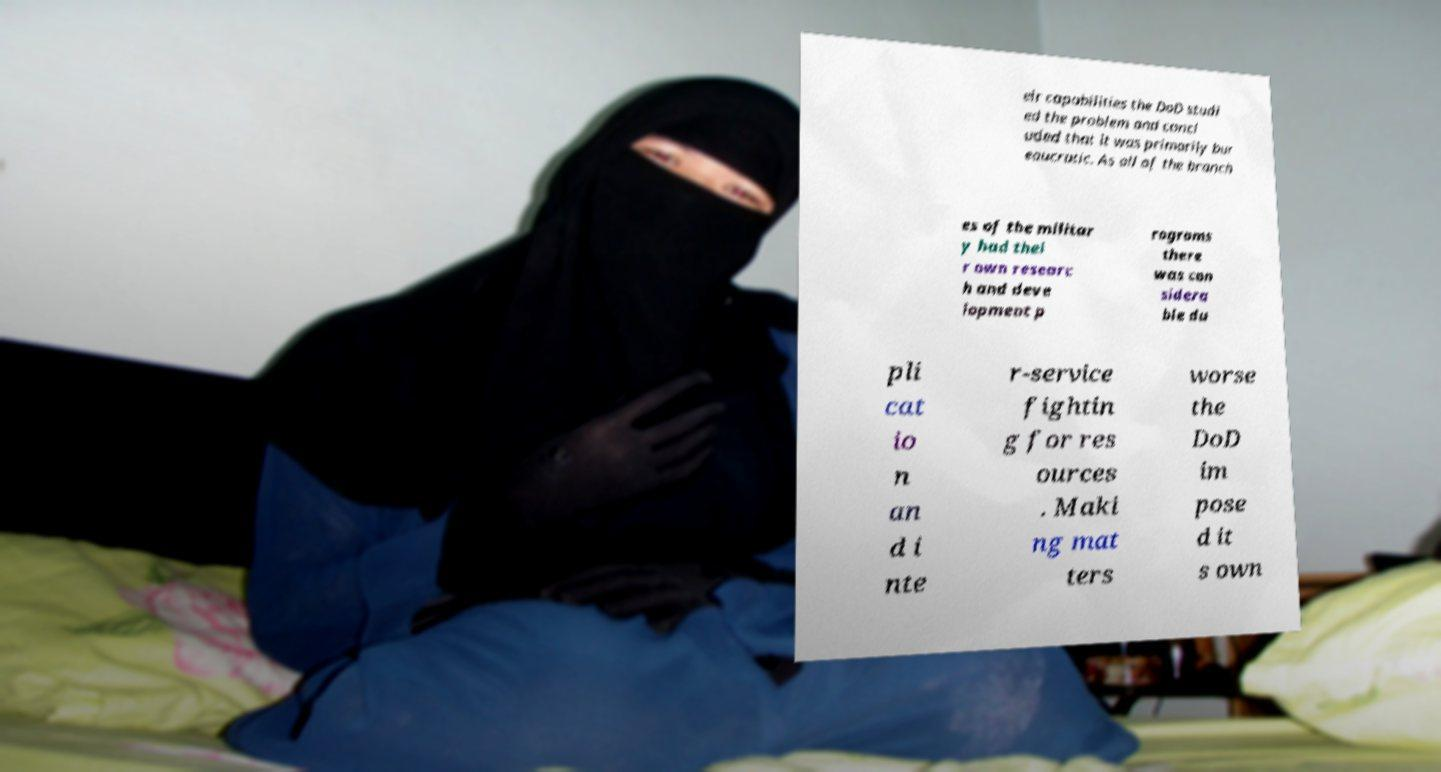What messages or text are displayed in this image? I need them in a readable, typed format. eir capabilities the DoD studi ed the problem and concl uded that it was primarily bur eaucratic. As all of the branch es of the militar y had thei r own researc h and deve lopment p rograms there was con sidera ble du pli cat io n an d i nte r-service fightin g for res ources . Maki ng mat ters worse the DoD im pose d it s own 